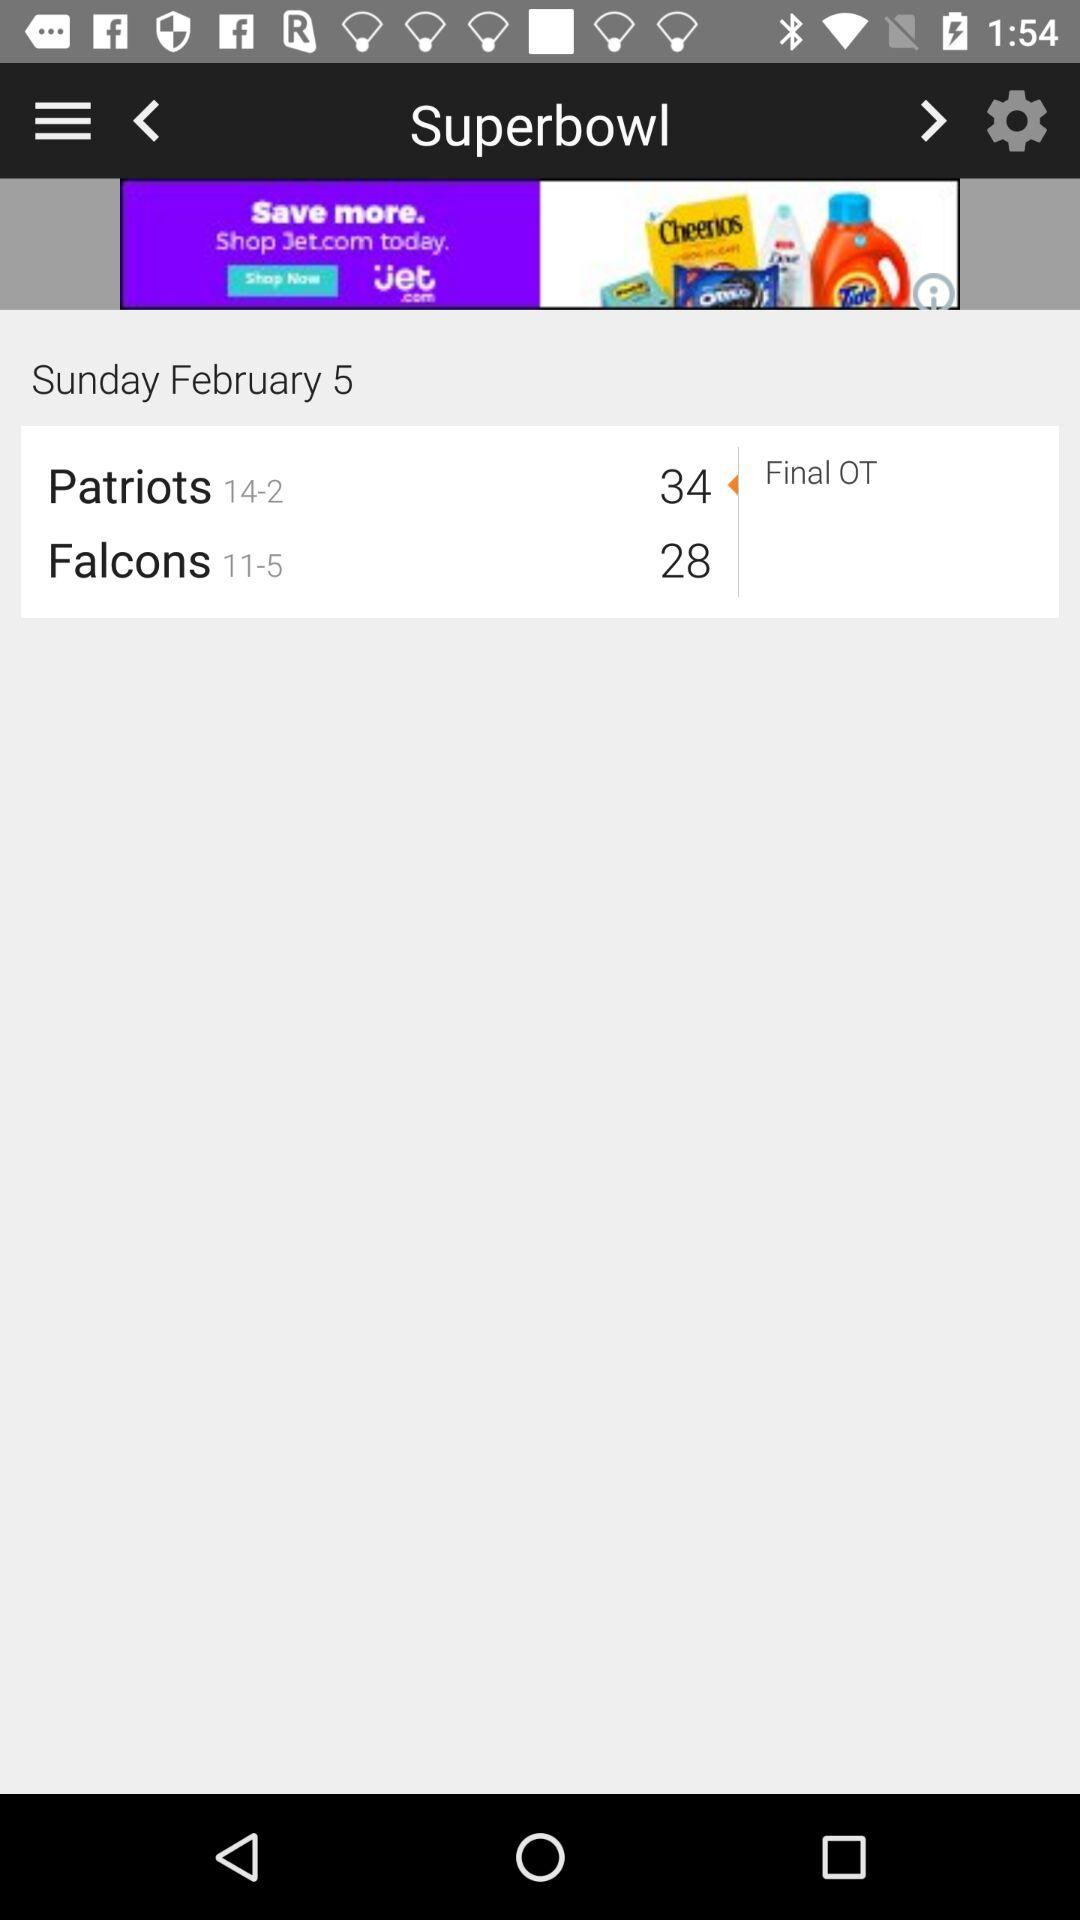What is the score of "Patriots"? The score of "Patriots" is 34. 